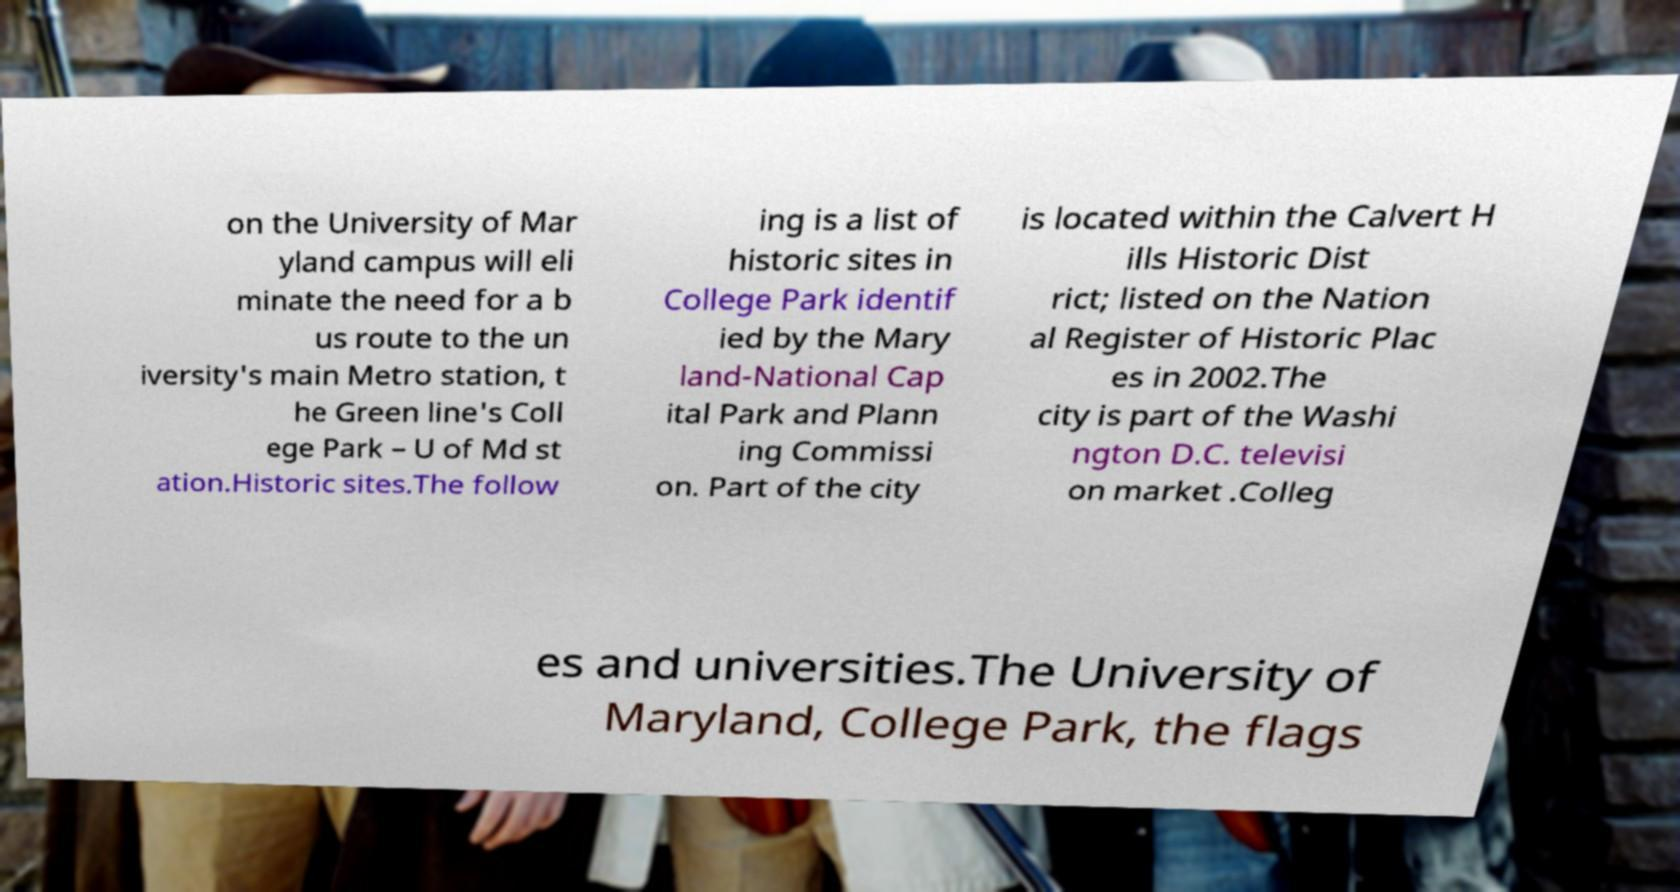Please read and relay the text visible in this image. What does it say? on the University of Mar yland campus will eli minate the need for a b us route to the un iversity's main Metro station, t he Green line's Coll ege Park – U of Md st ation.Historic sites.The follow ing is a list of historic sites in College Park identif ied by the Mary land-National Cap ital Park and Plann ing Commissi on. Part of the city is located within the Calvert H ills Historic Dist rict; listed on the Nation al Register of Historic Plac es in 2002.The city is part of the Washi ngton D.C. televisi on market .Colleg es and universities.The University of Maryland, College Park, the flags 